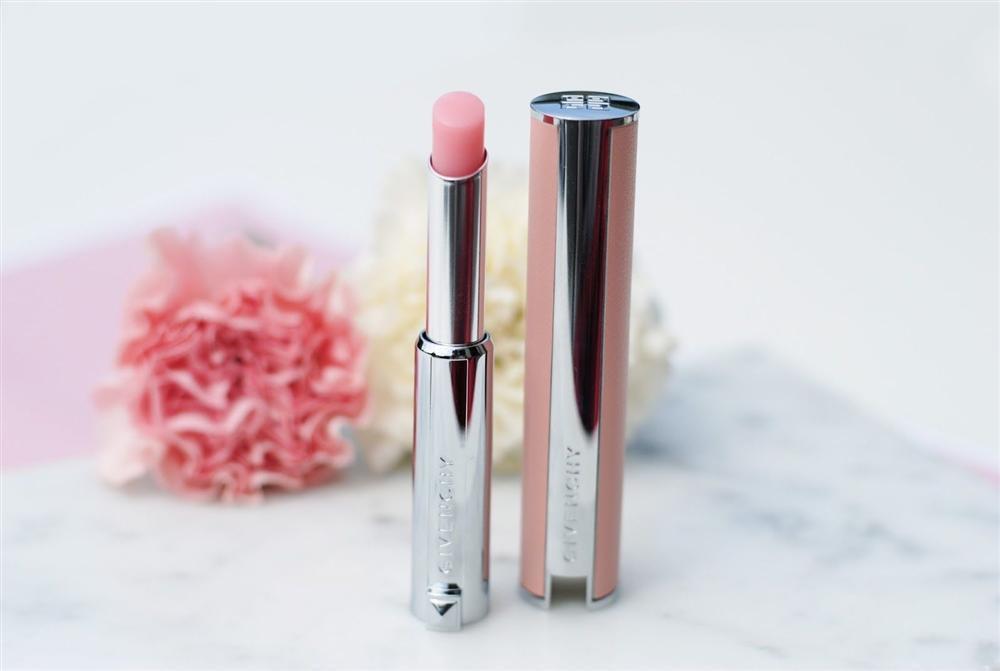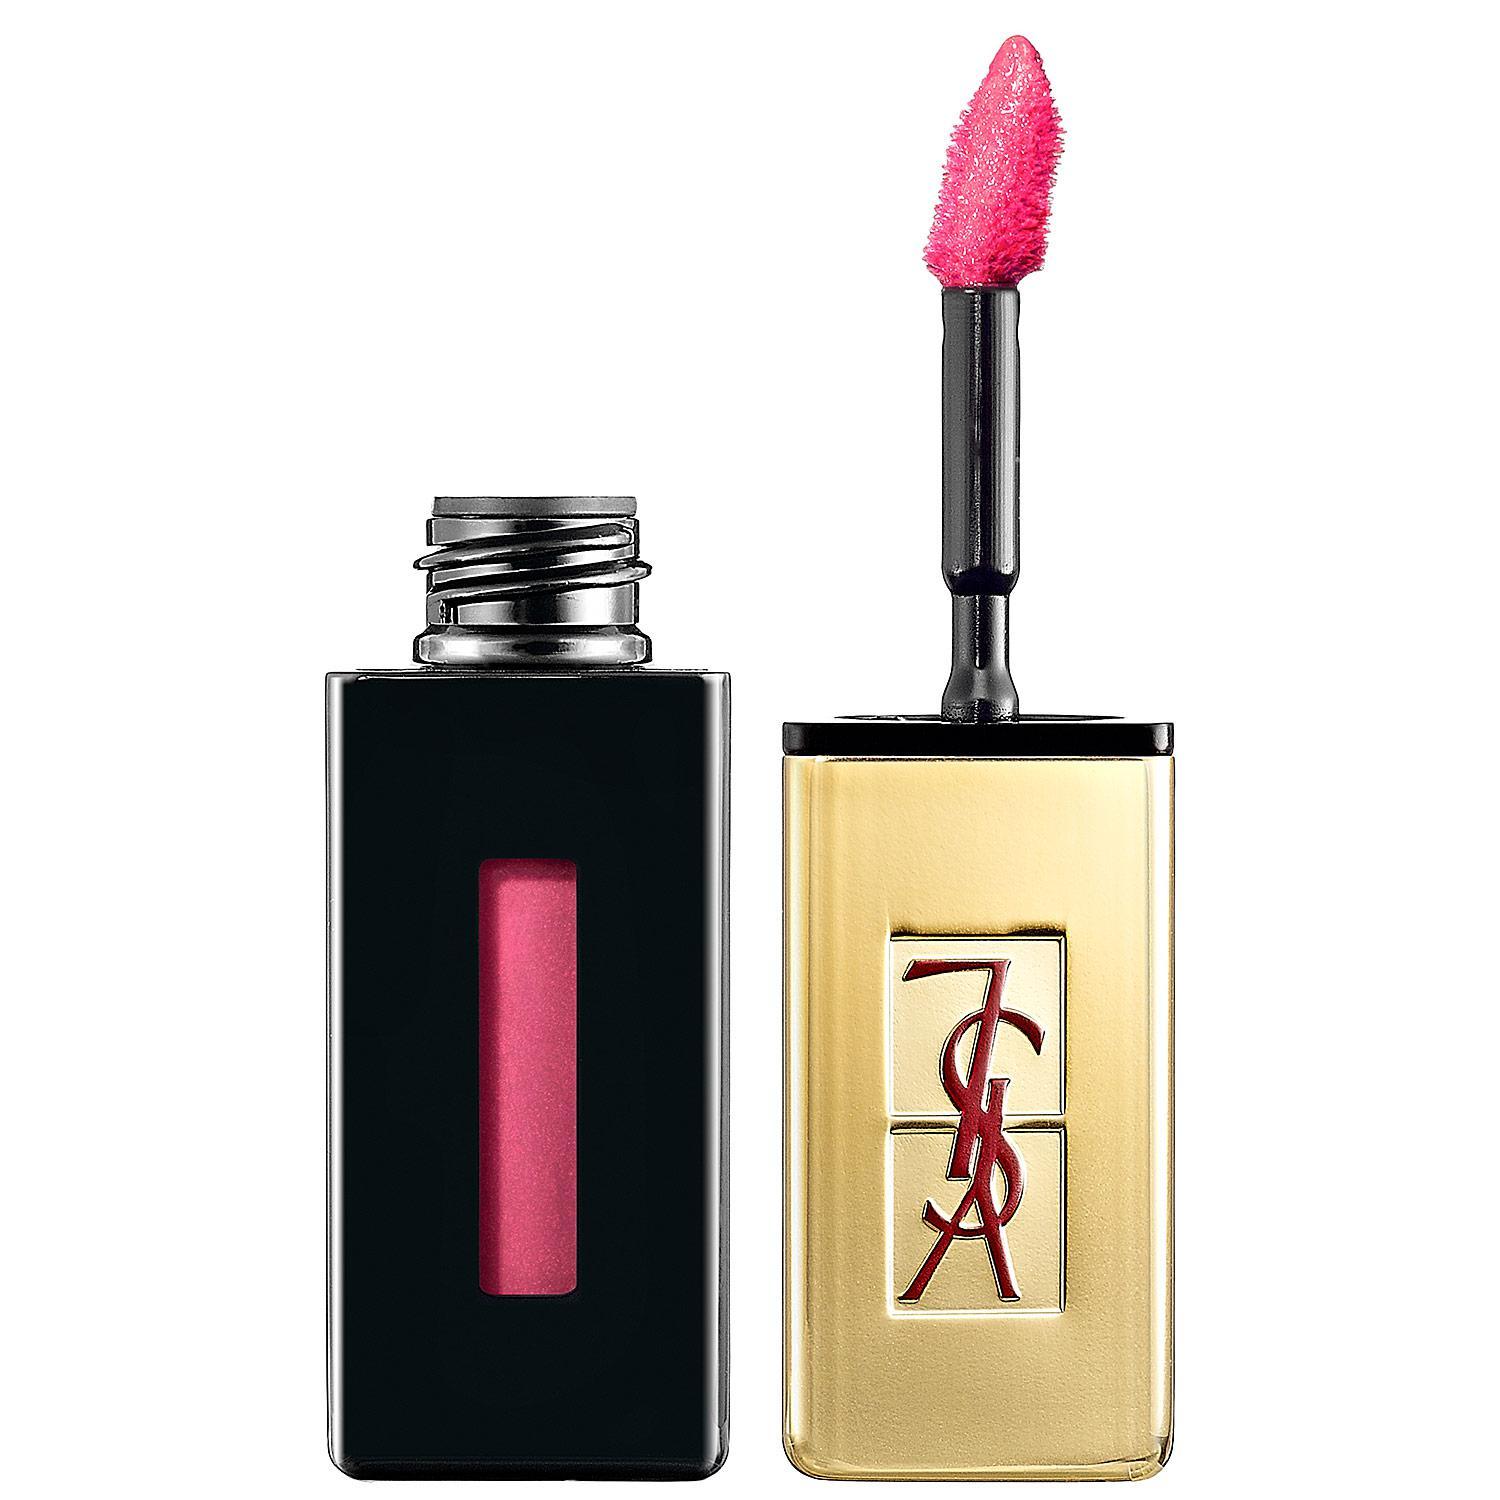The first image is the image on the left, the second image is the image on the right. Assess this claim about the two images: "Many shades of reddish lipstick are shown with the caps off in at least one of the pictures.". Correct or not? Answer yes or no. No. The first image is the image on the left, the second image is the image on the right. Examine the images to the left and right. Is the description "Someone is holding some lip stick." accurate? Answer yes or no. No. 